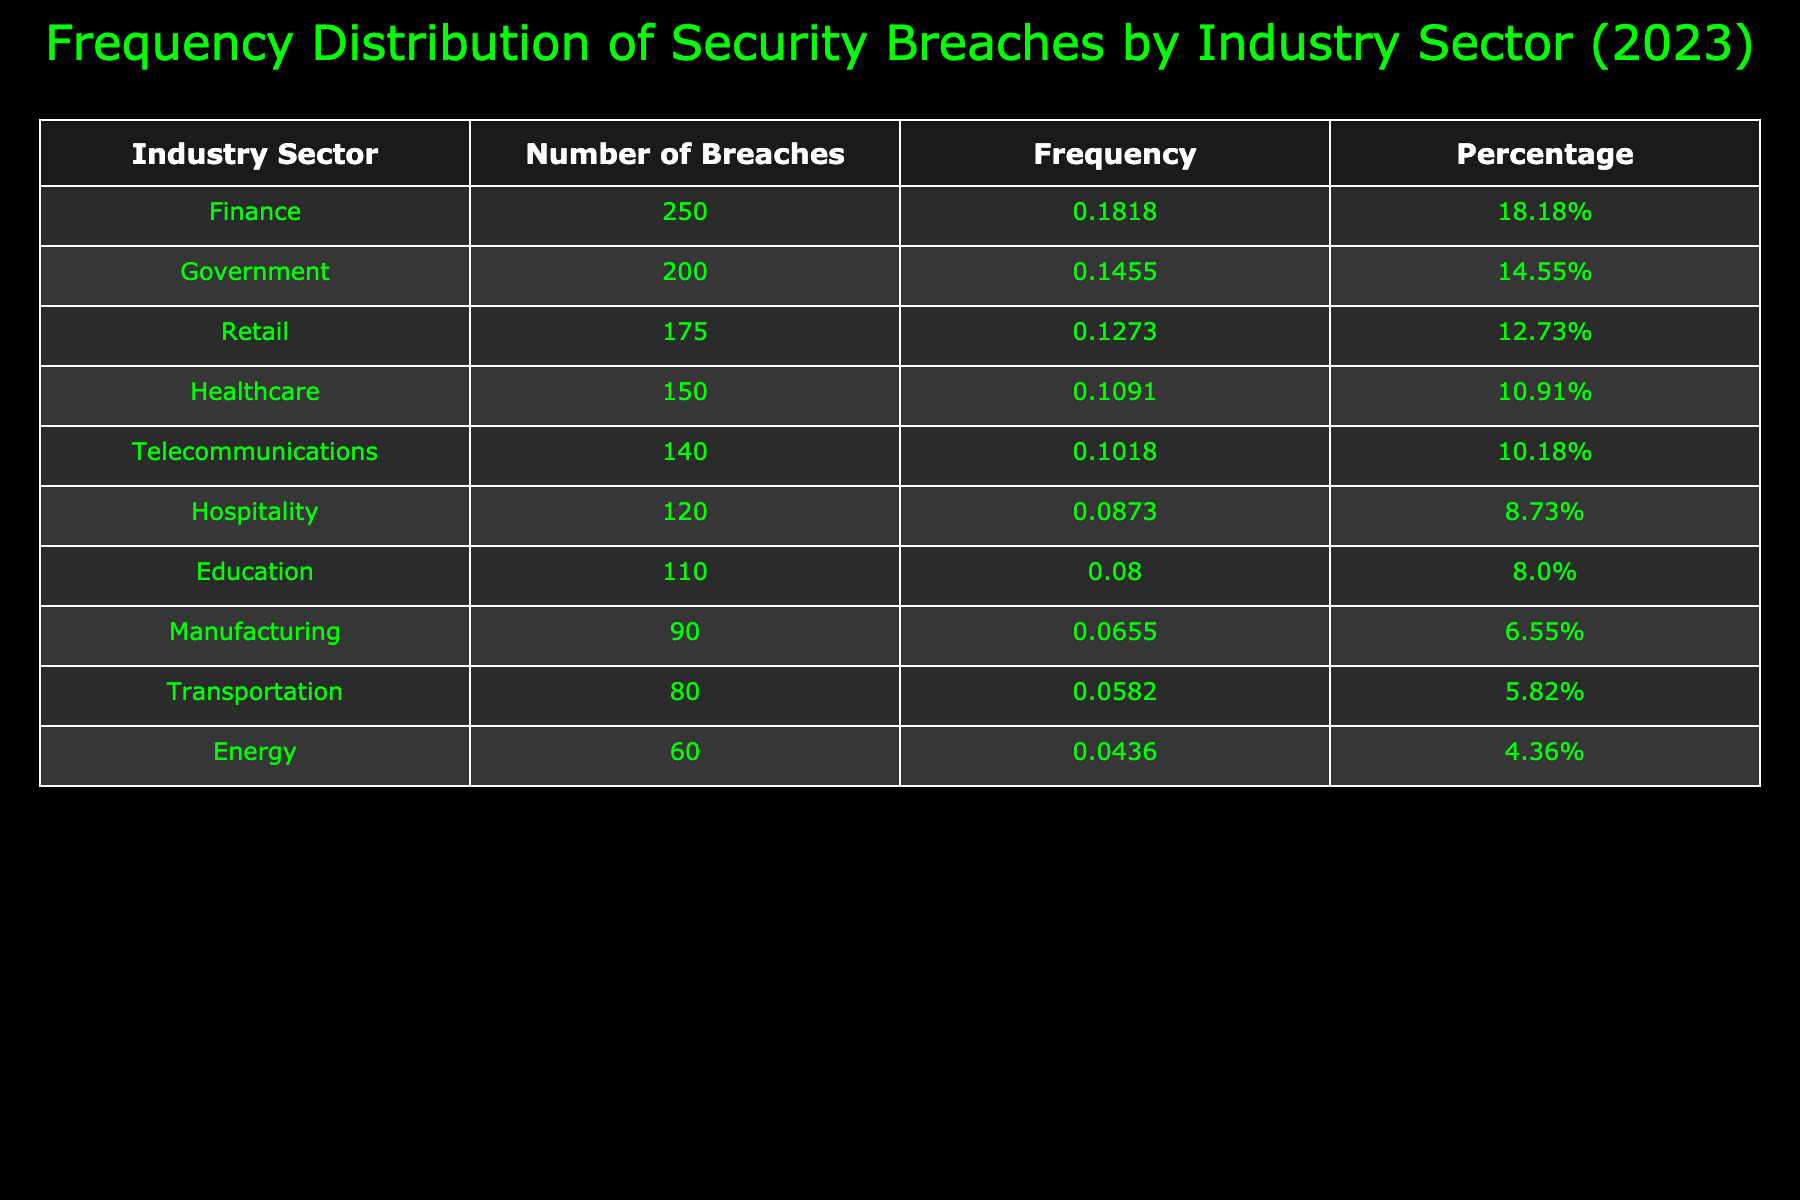What industry sector experienced the highest number of security breaches in 2023? The data from the table indicates that the Finance sector had the highest number of security breaches, totaling 250.
Answer: Finance What is the total number of security breaches across all industry sectors listed? To find the total, I add the number of breaches from each sector: 150 + 250 + 175 + 90 + 110 + 200 + 80 + 60 + 140 + 120 = 1375.
Answer: 1375 Which industry sector had the least number of security breaches? Looking through the table, the Energy sector had the least breaches with a total of 60.
Answer: Energy What percentage of the total security breaches were accounted for by the Healthcare sector? The number of breaches in Healthcare is 150. First, find the total breaches (1375) and calculate the percentage: (150 / 1375) * 100 = 10.91% (rounded to two decimal places).
Answer: 10.91% Is it true that the Government sector had more security breaches than the Education sector? Yes, the Government sector had 200 breaches while the Education sector had 110 breaches, so the statement is true.
Answer: Yes What is the average number of security breaches for the Manufacturing, Transportation, and Energy sectors combined? The total number of breaches for these three sectors is 90 (Manufacturing) + 80 (Transportation) + 60 (Energy) = 230. There are three sectors, so the average is 230 / 3 = 76.67 (rounded to two decimal places).
Answer: 76.67 How many more security breaches did the Finance sector have compared to the Telecommunications sector? The Finance sector had 250 breaches and Telecommunications had 140. The difference is 250 - 140 = 110.
Answer: 110 Which sector had a security breach count that was closer to the median of all sectors? First, we find the median by sorting the breach counts: [60, 80, 90, 110, 120, 140, 150, 175, 200, 250]. The median is the average of the 5th and 6th values: (120 + 140) / 2 = 130. The sector closest to 130 is Hospitality with 120.
Answer: Hospitality 